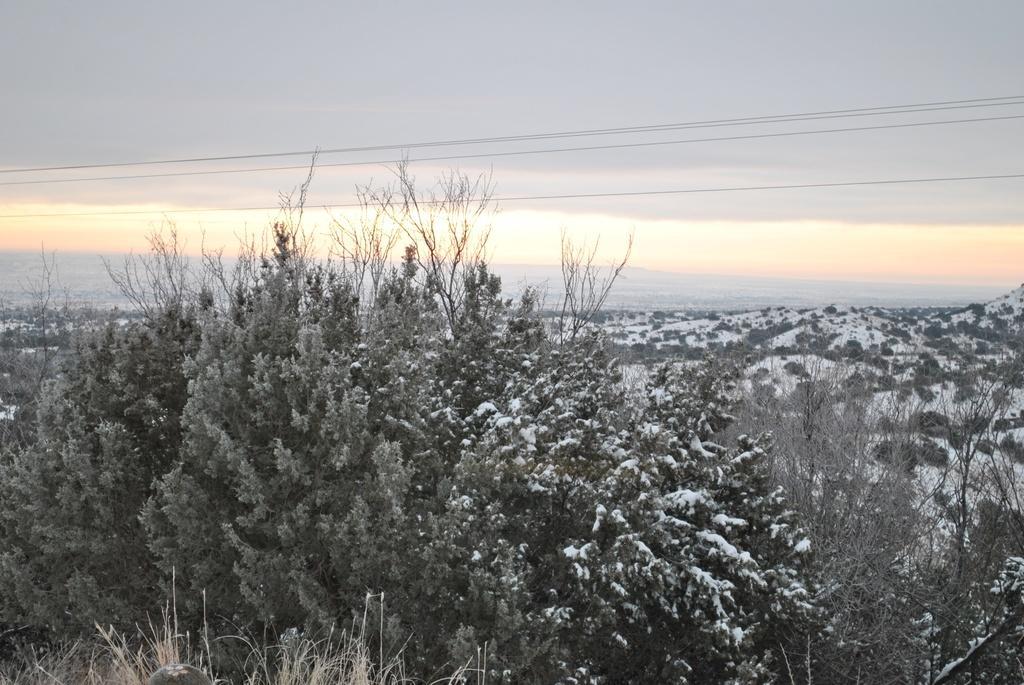How would you summarize this image in a sentence or two? There are trees, which are covered with snow in the foreground area of the image, it seems like mountains and the sky in the background. 